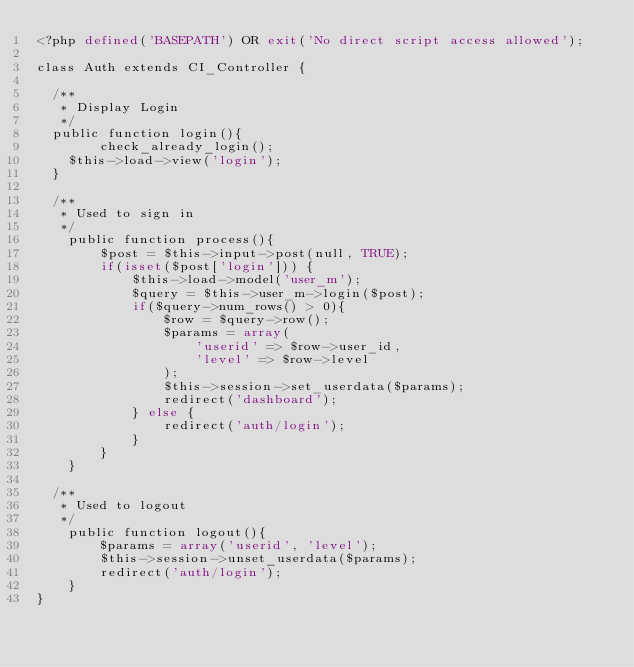Convert code to text. <code><loc_0><loc_0><loc_500><loc_500><_PHP_><?php defined('BASEPATH') OR exit('No direct script access allowed');

class Auth extends CI_Controller {

	/**
	 * Display Login
	 */
	public function login(){
        check_already_login();
		$this->load->view('login');
	}

	/**
	 * Used to sign in
	 */
    public function process(){
        $post = $this->input->post(null, TRUE);
        if(isset($post['login'])) {
            $this->load->model('user_m');
            $query = $this->user_m->login($post);
            if($query->num_rows() > 0){
                $row = $query->row();
                $params = array(
                    'userid' => $row->user_id,
                    'level' => $row->level
                );
                $this->session->set_userdata($params);
                redirect('dashboard');
            } else {
                redirect('auth/login');
            }
        }
    }

	/**
	 * Used to logout
	 */
    public function logout(){
        $params = array('userid', 'level');
        $this->session->unset_userdata($params);
        redirect('auth/login');
    }
}
</code> 